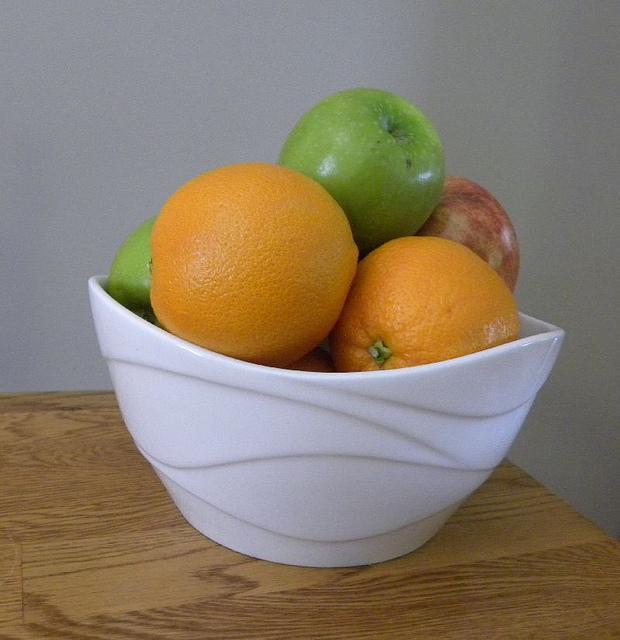How many fruits are in the bowl?
Give a very brief answer. 6. How many different fruits are pictured?
Give a very brief answer. 2. How many limes?
Give a very brief answer. 0. How many oranges are in the bowl?
Give a very brief answer. 2. How many fruit are in the bowl?
Give a very brief answer. 5. How many dishes are there?
Give a very brief answer. 1. How many oranges can be seen?
Give a very brief answer. 2. How many apples are there?
Give a very brief answer. 3. 